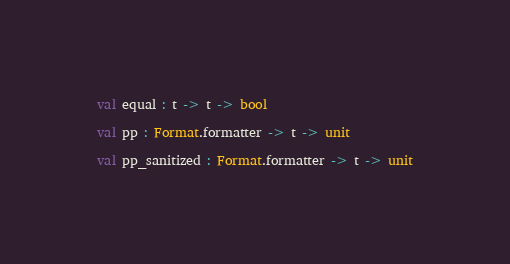<code> <loc_0><loc_0><loc_500><loc_500><_OCaml_>val equal : t -> t -> bool

val pp : Format.formatter -> t -> unit

val pp_sanitized : Format.formatter -> t -> unit
</code> 